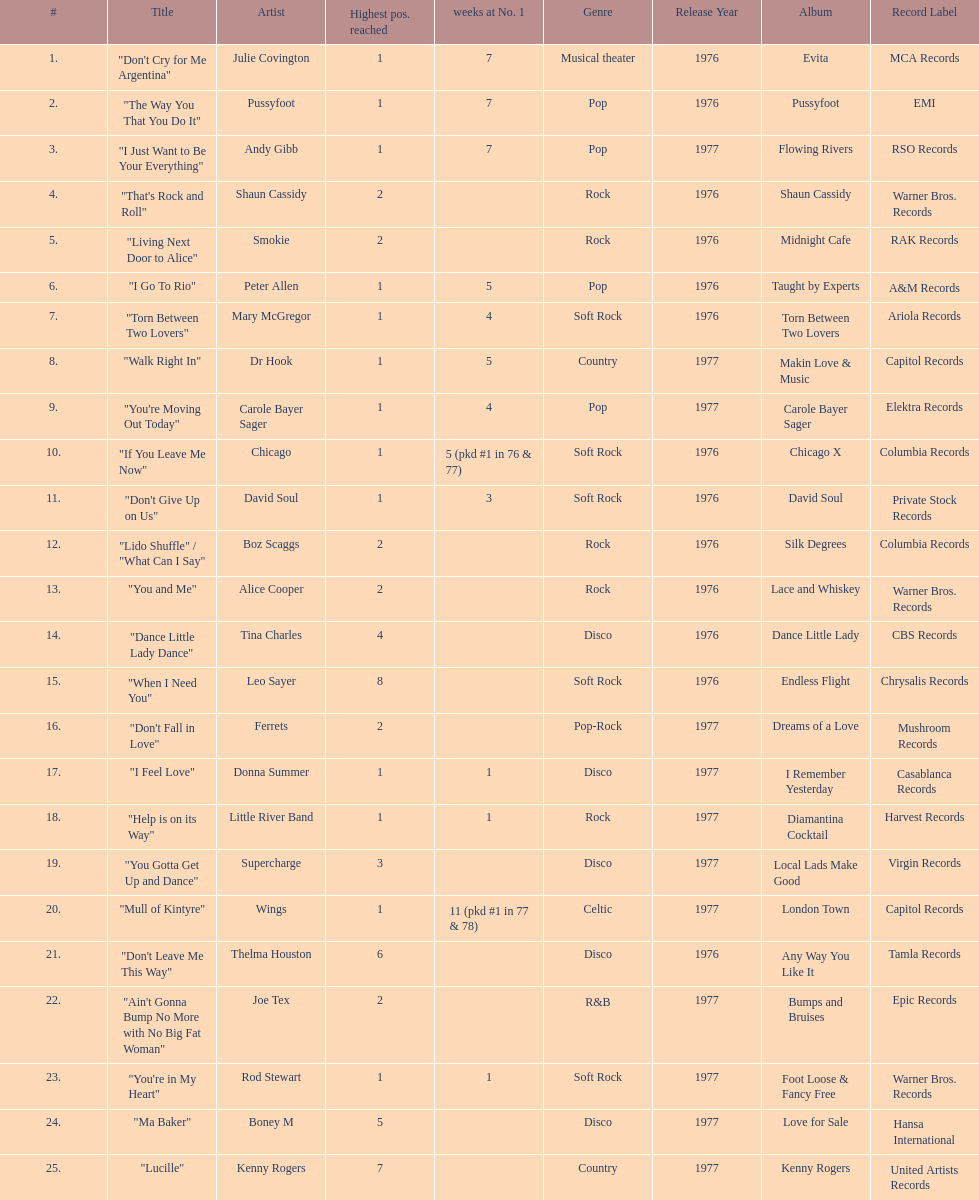Which song stayed at no.1 for the most amount of weeks. "Mull of Kintyre". 